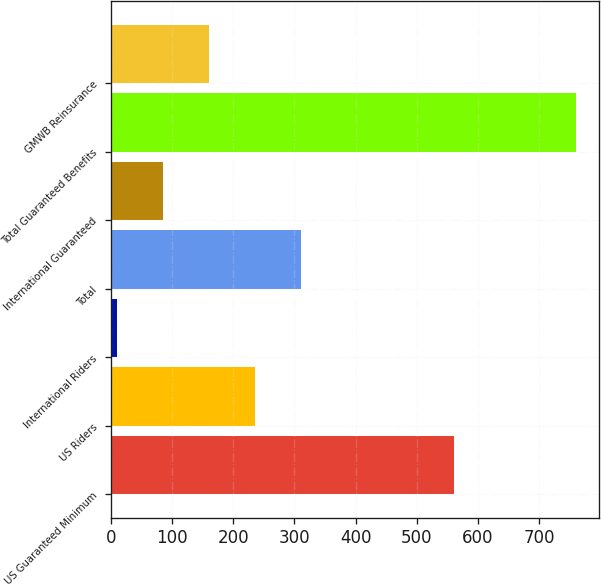Convert chart. <chart><loc_0><loc_0><loc_500><loc_500><bar_chart><fcel>US Guaranteed Minimum<fcel>US Riders<fcel>International Riders<fcel>Total<fcel>International Guaranteed<fcel>Total Guaranteed Benefits<fcel>GMWB Reinsurance<nl><fcel>561<fcel>235<fcel>10<fcel>310<fcel>85<fcel>760<fcel>160<nl></chart> 